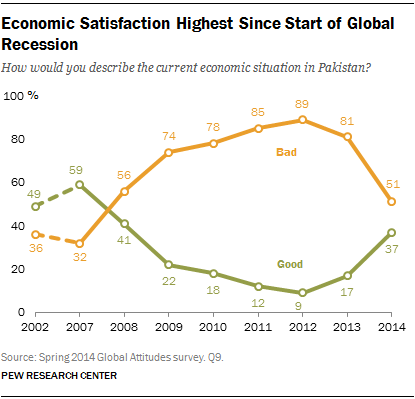Highlight a few significant elements in this photo. There are three green data points that have a value greater than 40. The line between bad and good crossed in the year 2007. 